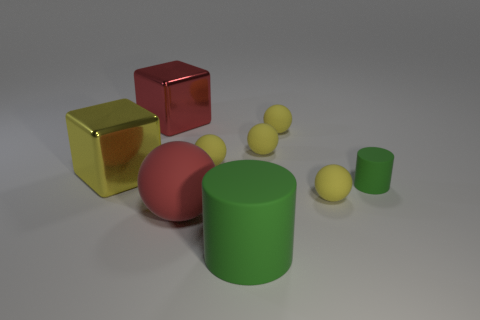Subtract all red matte spheres. How many spheres are left? 4 Subtract 1 cylinders. How many cylinders are left? 1 Add 1 large red balls. How many objects exist? 10 Subtract all brown cylinders. How many yellow balls are left? 4 Subtract all red balls. How many balls are left? 4 Subtract all cylinders. How many objects are left? 7 Subtract all purple rubber cubes. Subtract all big cylinders. How many objects are left? 8 Add 9 large red spheres. How many large red spheres are left? 10 Add 2 big yellow shiny cubes. How many big yellow shiny cubes exist? 3 Subtract 0 blue spheres. How many objects are left? 9 